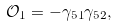<formula> <loc_0><loc_0><loc_500><loc_500>\mathcal { O } _ { 1 } = - \gamma _ { 5 1 } \gamma _ { 5 2 } ,</formula> 